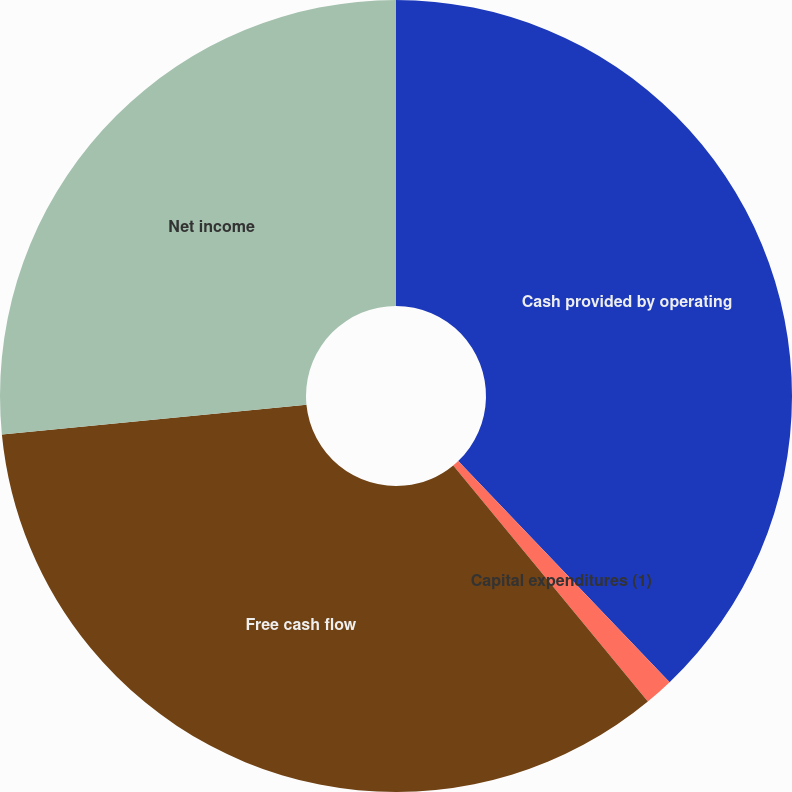Convert chart. <chart><loc_0><loc_0><loc_500><loc_500><pie_chart><fcel>Cash provided by operating<fcel>Capital expenditures (1)<fcel>Free cash flow<fcel>Net income<nl><fcel>37.86%<fcel>1.17%<fcel>34.42%<fcel>26.55%<nl></chart> 